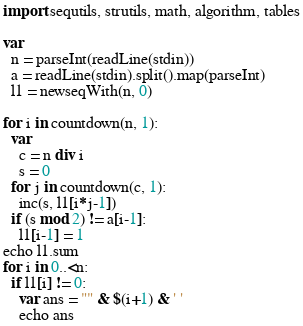Convert code to text. <code><loc_0><loc_0><loc_500><loc_500><_Nim_>import sequtils, strutils, math, algorithm, tables

var
  n = parseInt(readLine(stdin))
  a = readLine(stdin).split().map(parseInt)
  l1 = newseqWith(n, 0)

for i in countdown(n, 1):
  var
    c = n div i
    s = 0
  for j in countdown(c, 1):
    inc(s, l1[i*j-1])
  if (s mod 2) != a[i-1]:
    l1[i-1] = 1
echo l1.sum
for i in 0..<n:
  if l1[i] != 0:
    var ans = "" & $(i+1) & ' '
    echo ans

</code> 